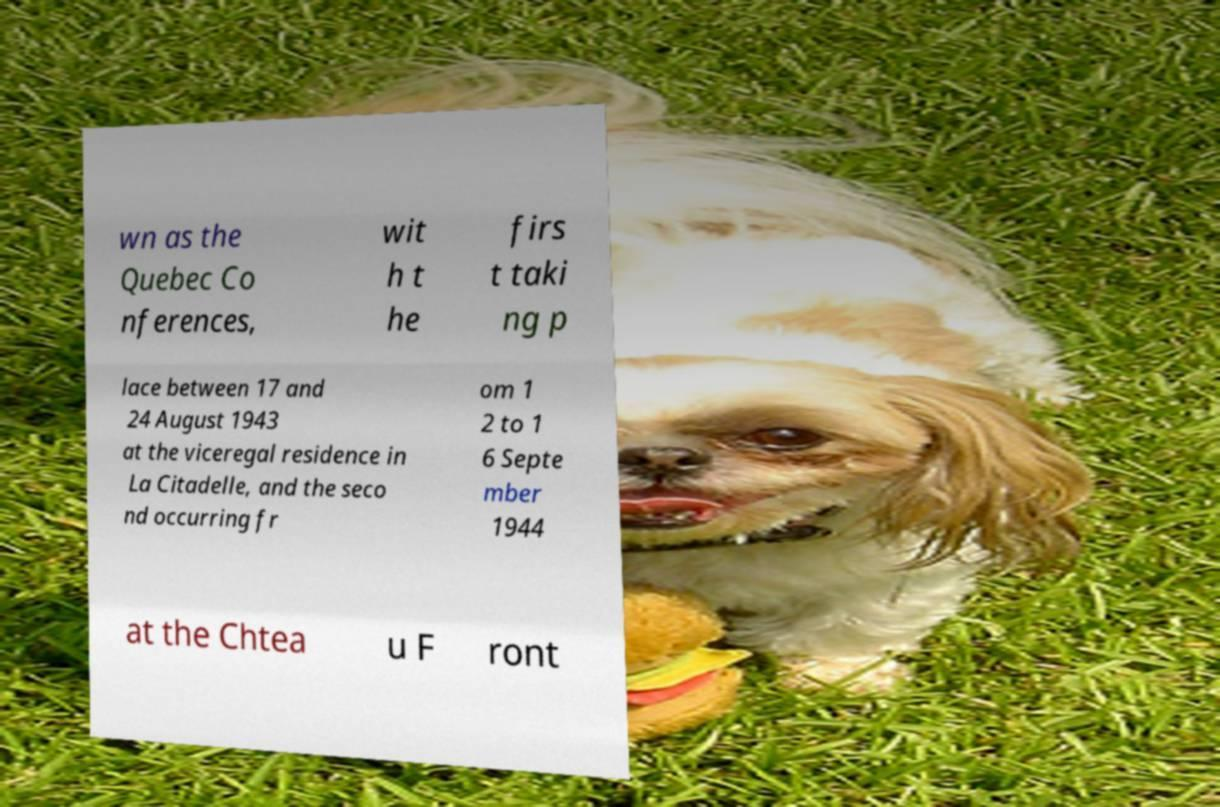There's text embedded in this image that I need extracted. Can you transcribe it verbatim? wn as the Quebec Co nferences, wit h t he firs t taki ng p lace between 17 and 24 August 1943 at the viceregal residence in La Citadelle, and the seco nd occurring fr om 1 2 to 1 6 Septe mber 1944 at the Chtea u F ront 